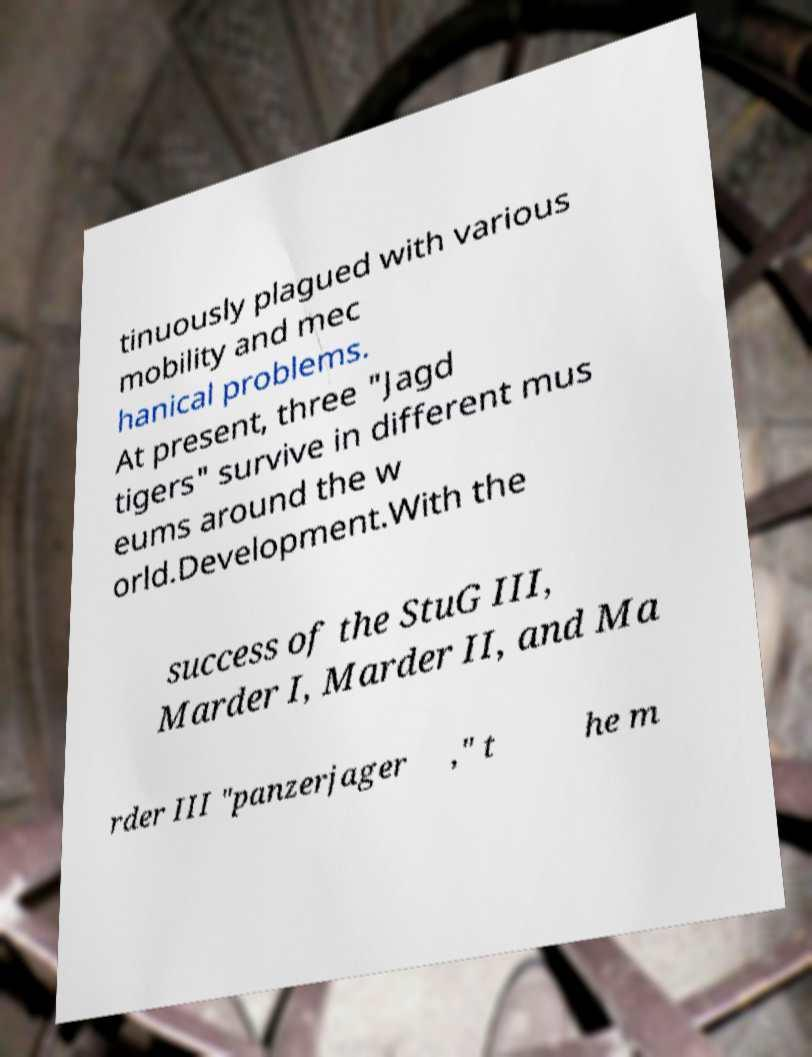For documentation purposes, I need the text within this image transcribed. Could you provide that? tinuously plagued with various mobility and mec hanical problems. At present, three "Jagd tigers" survive in different mus eums around the w orld.Development.With the success of the StuG III, Marder I, Marder II, and Ma rder III "panzerjager ," t he m 